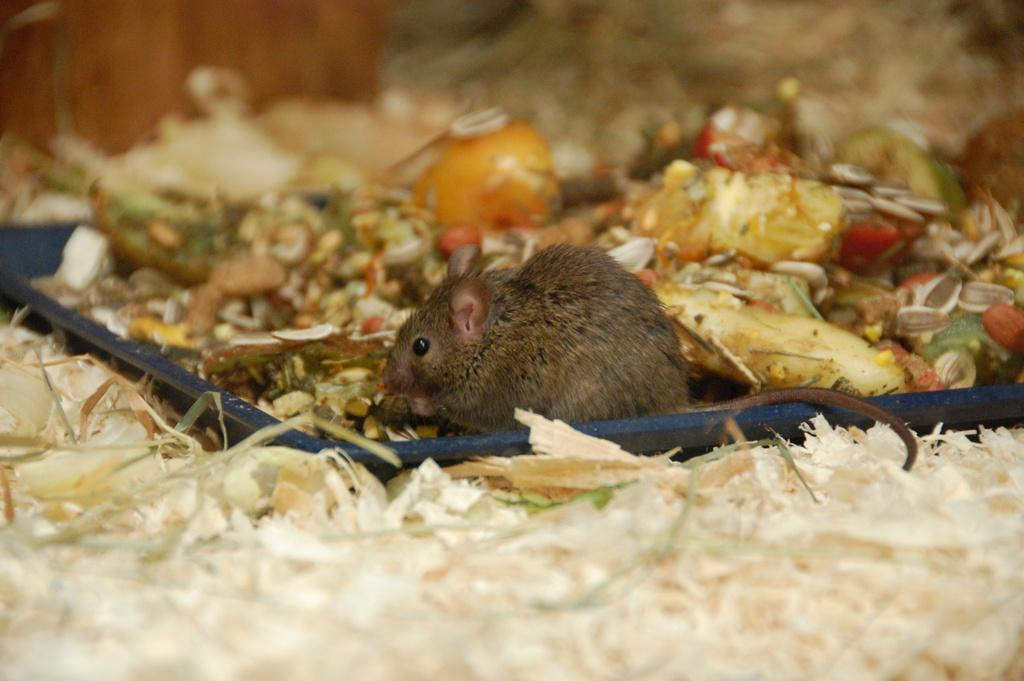What type of animal is present in the image? There is a rat in the image. What is the rat sitting on in the image? The rat is sitting on the garbage in the image. What else can be seen in the image besides the rat? There is garbage visible in the image. What type of tree can be seen in the image? There is no tree present in the image; it features a rat sitting on garbage. Is the rat's uncle visible in the image? There is no reference to an uncle or any other person in the image, only a rat sitting on garbage. 